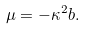<formula> <loc_0><loc_0><loc_500><loc_500>\mu = - \kappa ^ { 2 } b .</formula> 